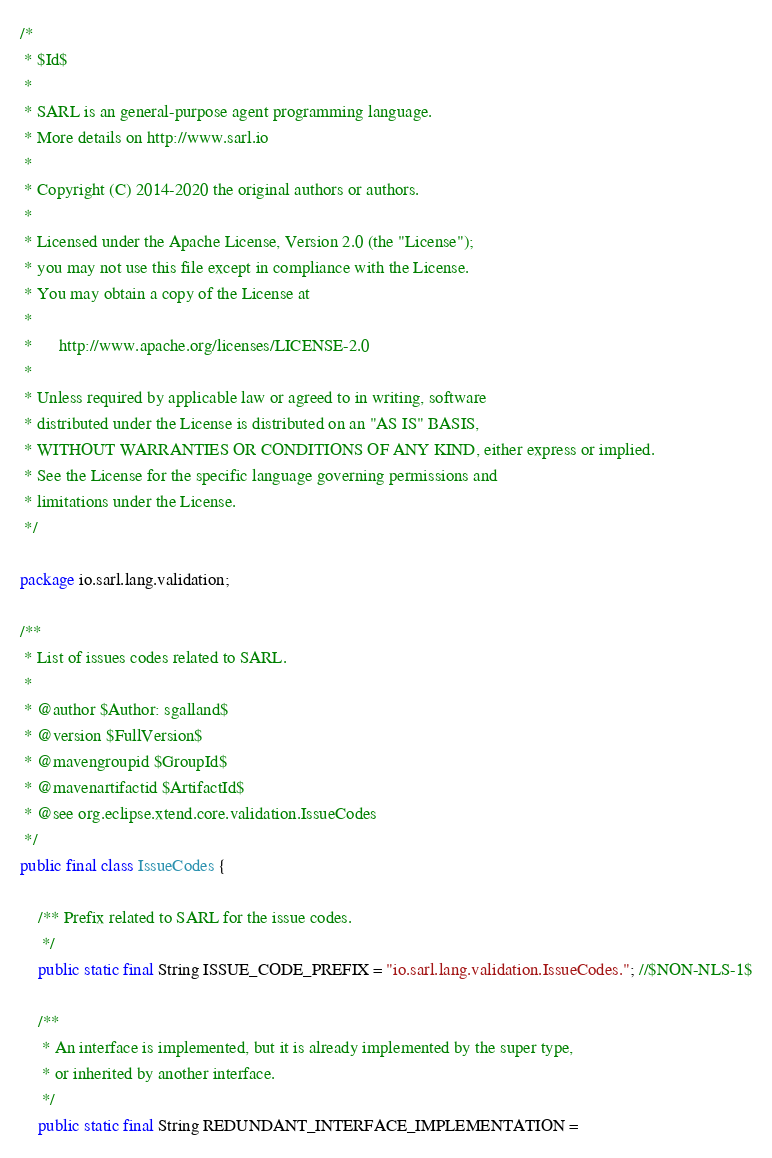Convert code to text. <code><loc_0><loc_0><loc_500><loc_500><_Java_>/*
 * $Id$
 *
 * SARL is an general-purpose agent programming language.
 * More details on http://www.sarl.io
 *
 * Copyright (C) 2014-2020 the original authors or authors.
 *
 * Licensed under the Apache License, Version 2.0 (the "License");
 * you may not use this file except in compliance with the License.
 * You may obtain a copy of the License at
 *
 *      http://www.apache.org/licenses/LICENSE-2.0
 *
 * Unless required by applicable law or agreed to in writing, software
 * distributed under the License is distributed on an "AS IS" BASIS,
 * WITHOUT WARRANTIES OR CONDITIONS OF ANY KIND, either express or implied.
 * See the License for the specific language governing permissions and
 * limitations under the License.
 */

package io.sarl.lang.validation;

/**
 * List of issues codes related to SARL.
 *
 * @author $Author: sgalland$
 * @version $FullVersion$
 * @mavengroupid $GroupId$
 * @mavenartifactid $ArtifactId$
 * @see org.eclipse.xtend.core.validation.IssueCodes
 */
public final class IssueCodes {

	/** Prefix related to SARL for the issue codes.
	 */
	public static final String ISSUE_CODE_PREFIX = "io.sarl.lang.validation.IssueCodes."; //$NON-NLS-1$

	/**
	 * An interface is implemented, but it is already implemented by the super type,
	 * or inherited by another interface.
	 */
	public static final String REDUNDANT_INTERFACE_IMPLEMENTATION =</code> 